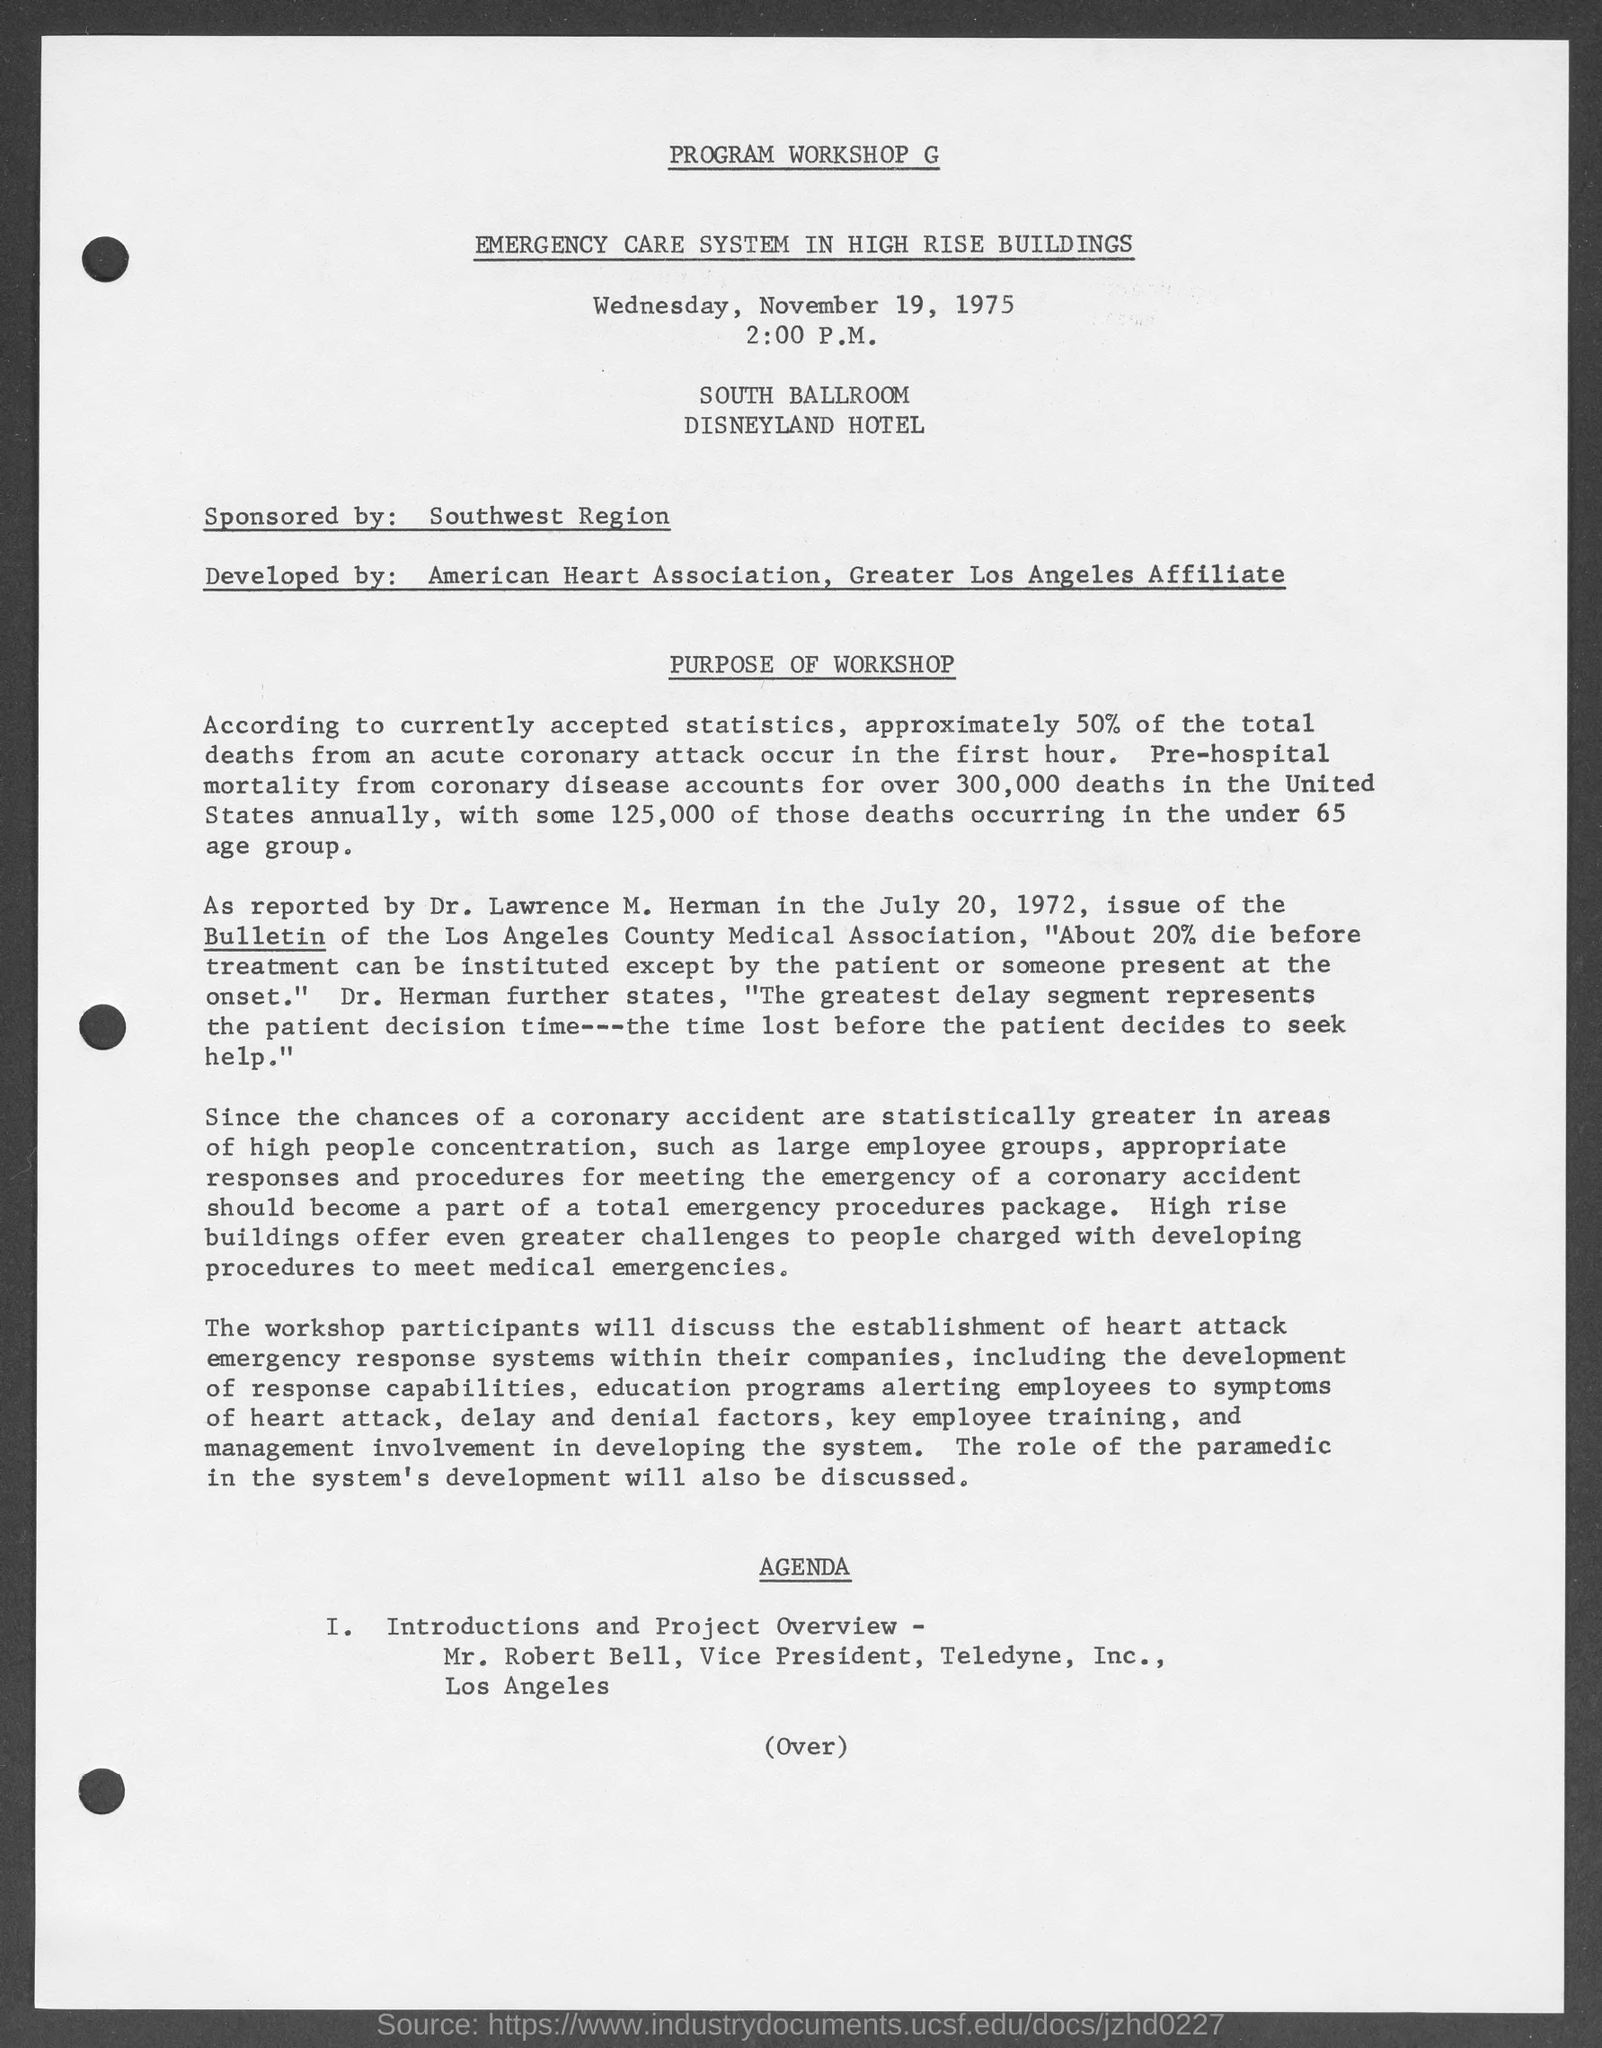Point out several critical features in this image. The sponsor for the given program is the Southwest Region. The given program is scheduled to start at 2:00 P.M. The scheduled date of the given program is Wednesday, November 19, 1975. Mr. Robert Bell's designation is Vice President. The hotel mentioned in the given program is called Disneyland Hotel. 